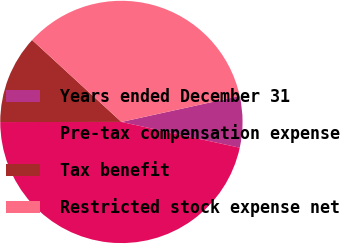<chart> <loc_0><loc_0><loc_500><loc_500><pie_chart><fcel>Years ended December 31<fcel>Pre-tax compensation expense<fcel>Tax benefit<fcel>Restricted stock expense net<nl><fcel>6.85%<fcel>46.58%<fcel>11.83%<fcel>34.75%<nl></chart> 